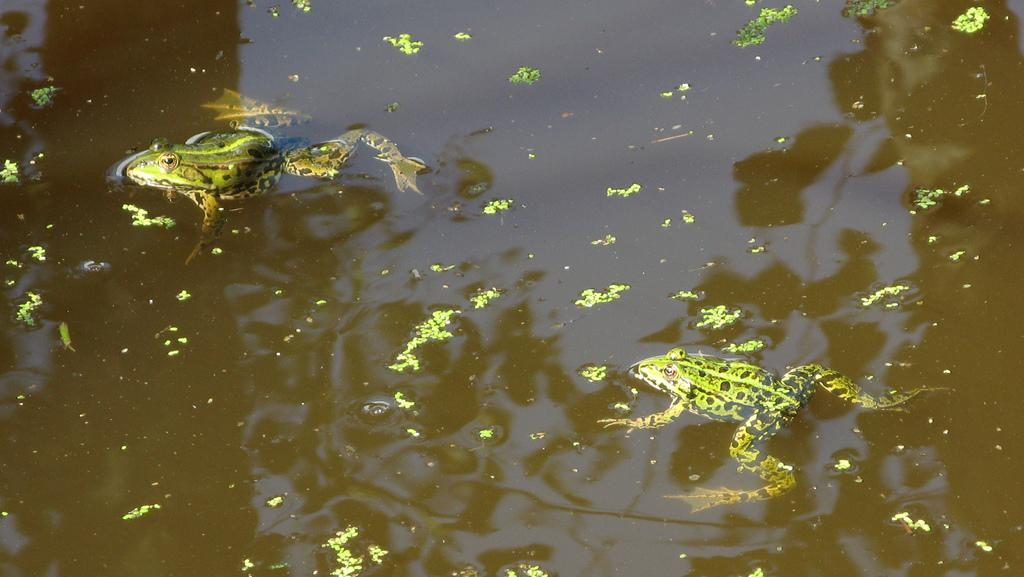What is the primary element visible in the image? The water is visible in the image. What can be observed in the water? There is green algae in the water. Are there any animals present in the image? Yes, there are two frogs in the water. What time of day is it in the image when the thunder is heard? There is no thunder present in the image, so it is not possible to determine the time of day based on that information. 